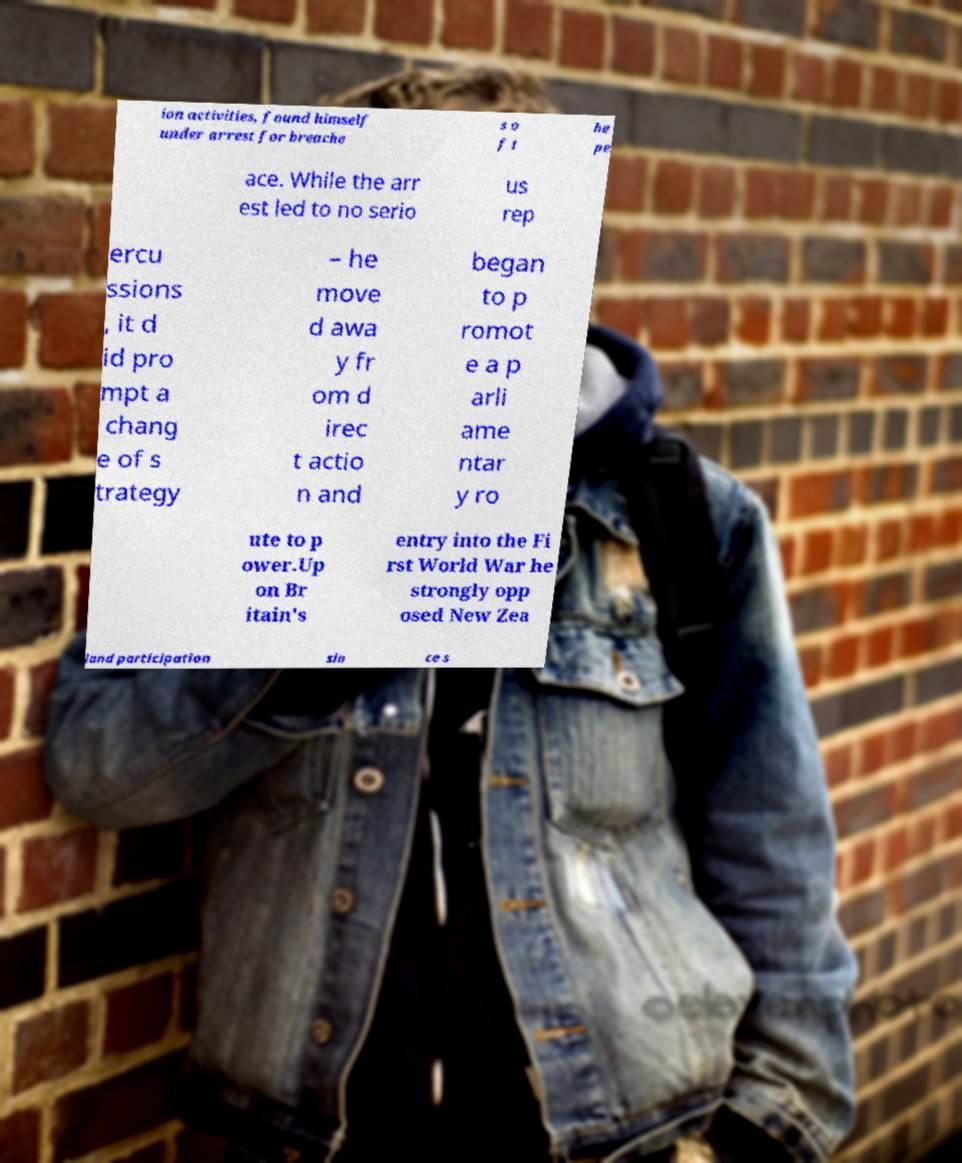Can you accurately transcribe the text from the provided image for me? ion activities, found himself under arrest for breache s o f t he pe ace. While the arr est led to no serio us rep ercu ssions , it d id pro mpt a chang e of s trategy – he move d awa y fr om d irec t actio n and began to p romot e a p arli ame ntar y ro ute to p ower.Up on Br itain's entry into the Fi rst World War he strongly opp osed New Zea land participation sin ce s 